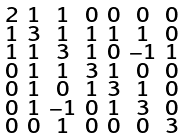<formula> <loc_0><loc_0><loc_500><loc_500>\begin{smallmatrix} 2 & 1 & 1 & 0 & 0 & 0 & 0 \\ 1 & 3 & 1 & 1 & 1 & 1 & 0 \\ 1 & 1 & 3 & 1 & 0 & - 1 & 1 \\ 0 & 1 & 1 & 3 & 1 & 0 & 0 \\ 0 & 1 & 0 & 1 & 3 & 1 & 0 \\ 0 & 1 & - 1 & 0 & 1 & 3 & 0 \\ 0 & 0 & 1 & 0 & 0 & 0 & 3 \end{smallmatrix}</formula> 